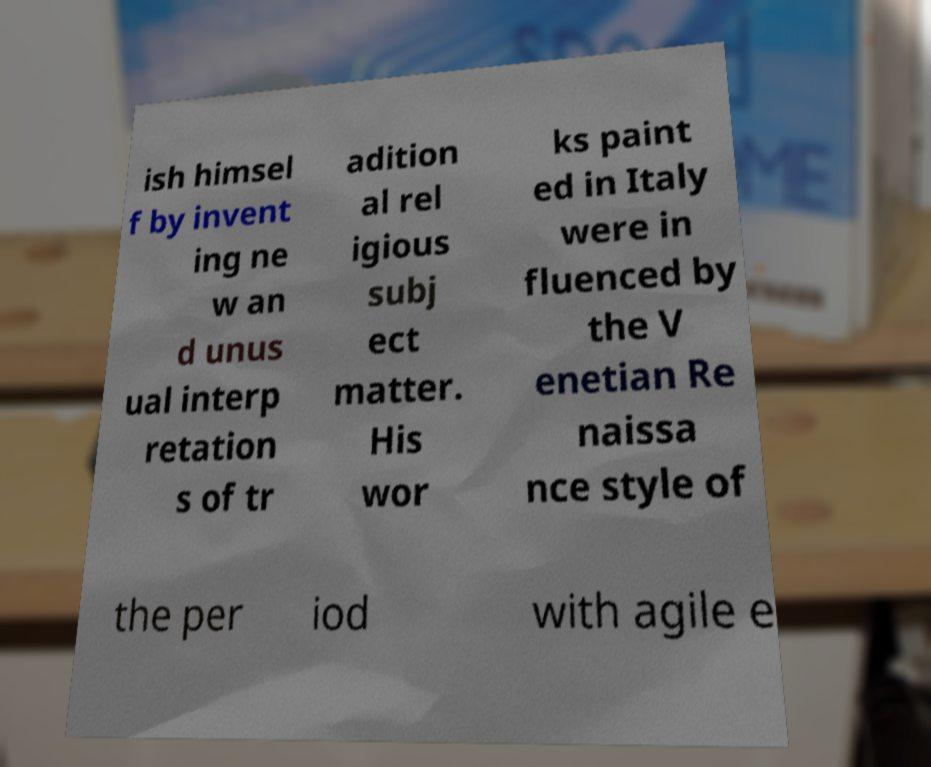Please identify and transcribe the text found in this image. ish himsel f by invent ing ne w an d unus ual interp retation s of tr adition al rel igious subj ect matter. His wor ks paint ed in Italy were in fluenced by the V enetian Re naissa nce style of the per iod with agile e 